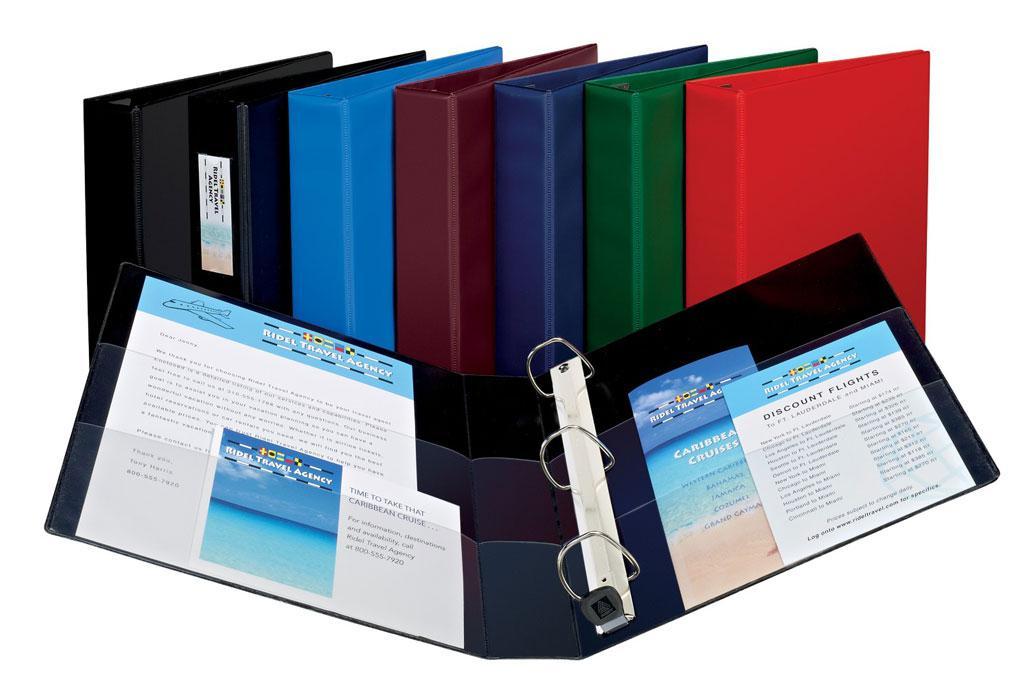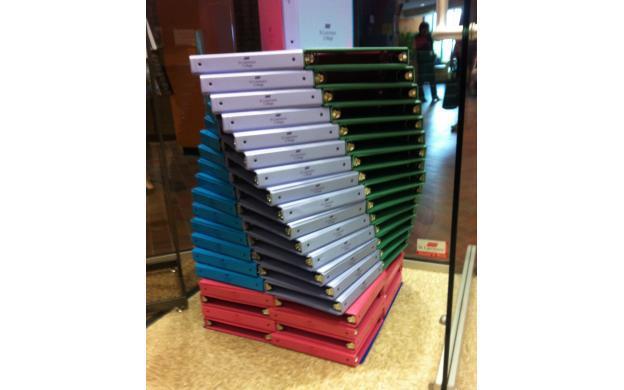The first image is the image on the left, the second image is the image on the right. Evaluate the accuracy of this statement regarding the images: "binders are stacked on their sides with paper inside". Is it true? Answer yes or no. No. The first image is the image on the left, the second image is the image on the right. Considering the images on both sides, is "The left image has at least four binders stacked vertically in it." valid? Answer yes or no. No. 